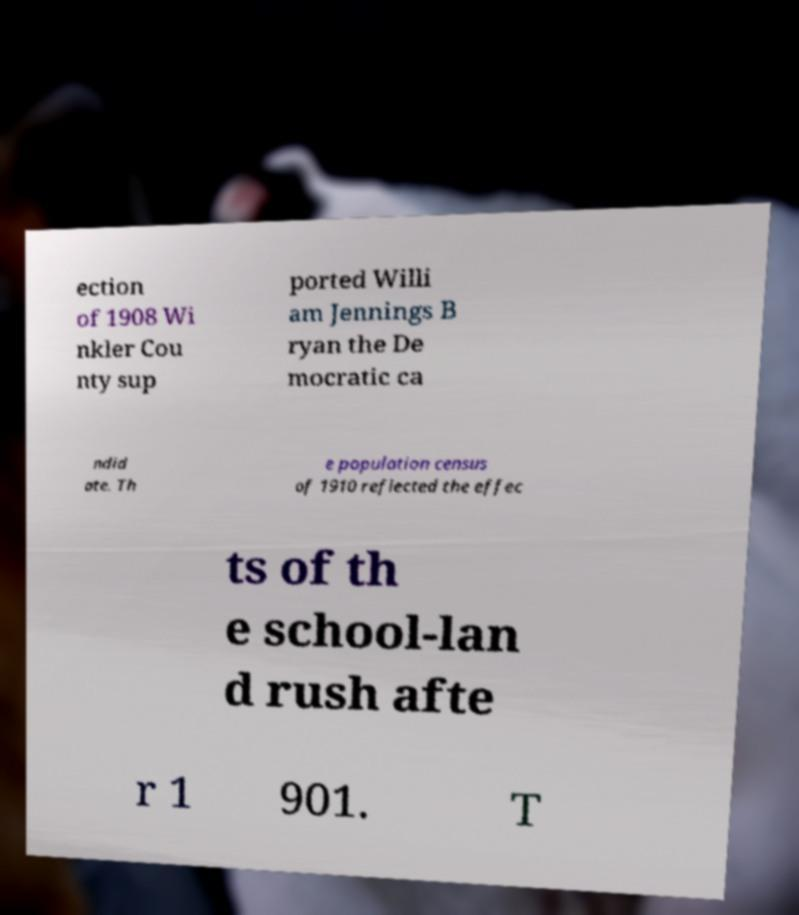There's text embedded in this image that I need extracted. Can you transcribe it verbatim? ection of 1908 Wi nkler Cou nty sup ported Willi am Jennings B ryan the De mocratic ca ndid ate. Th e population census of 1910 reflected the effec ts of th e school-lan d rush afte r 1 901. T 